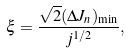Convert formula to latex. <formula><loc_0><loc_0><loc_500><loc_500>\xi = \frac { \sqrt { 2 } ( \Delta J _ { n } ) _ { \min } } { j ^ { 1 / 2 } } ,</formula> 